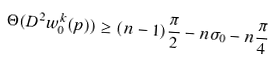<formula> <loc_0><loc_0><loc_500><loc_500>\Theta ( D ^ { 2 } w ^ { k } _ { 0 } ( p ) ) \geq ( n - 1 ) \frac { \pi } { 2 } - n \sigma _ { 0 } - n \frac { \pi } { 4 }</formula> 